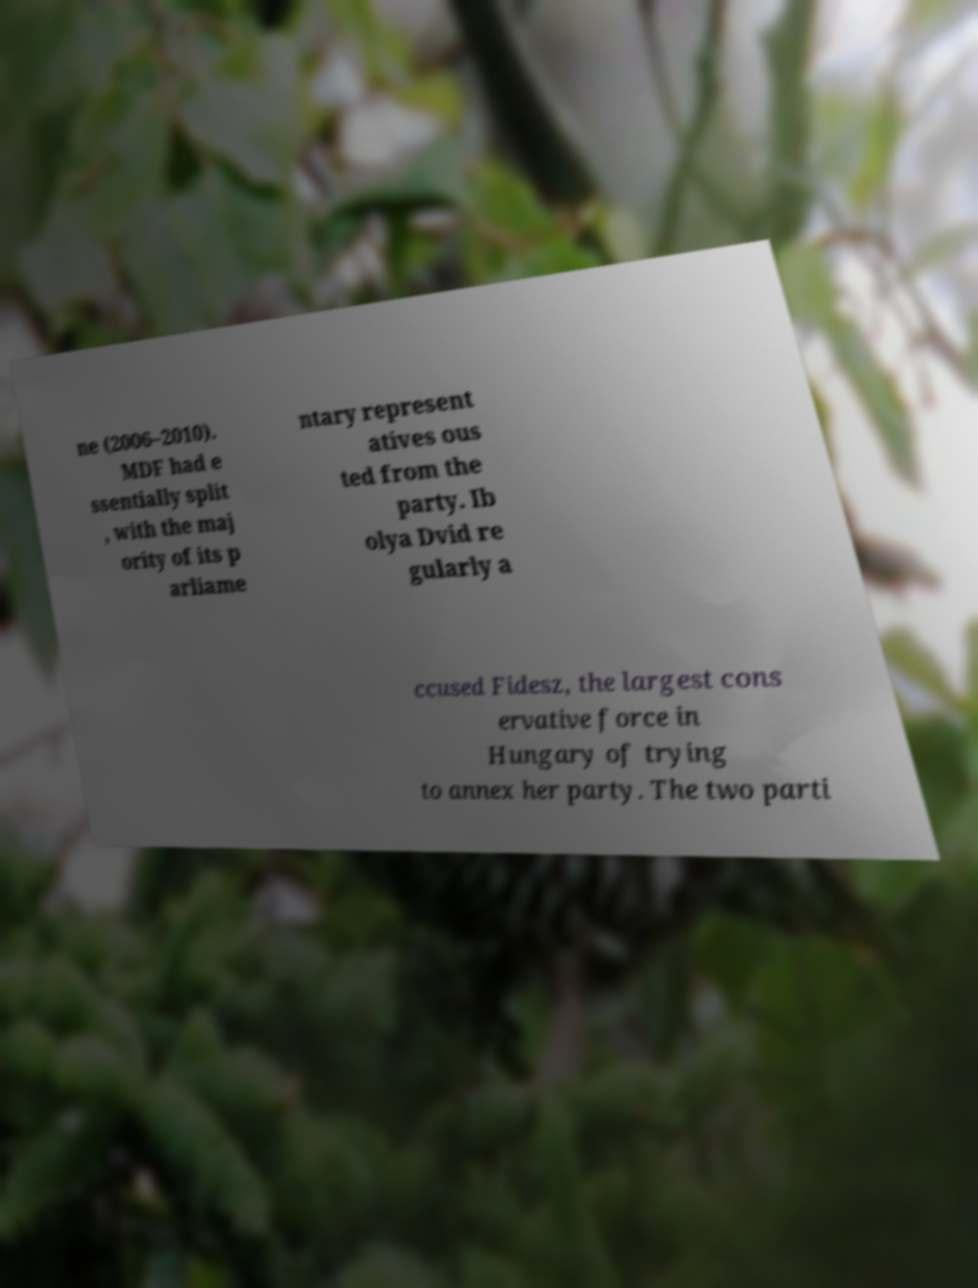Please identify and transcribe the text found in this image. ne (2006–2010). MDF had e ssentially split , with the maj ority of its p arliame ntary represent atives ous ted from the party. Ib olya Dvid re gularly a ccused Fidesz, the largest cons ervative force in Hungary of trying to annex her party. The two parti 